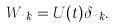Convert formula to latex. <formula><loc_0><loc_0><loc_500><loc_500>W _ { n k } = U ( t ) \delta _ { n k } .</formula> 